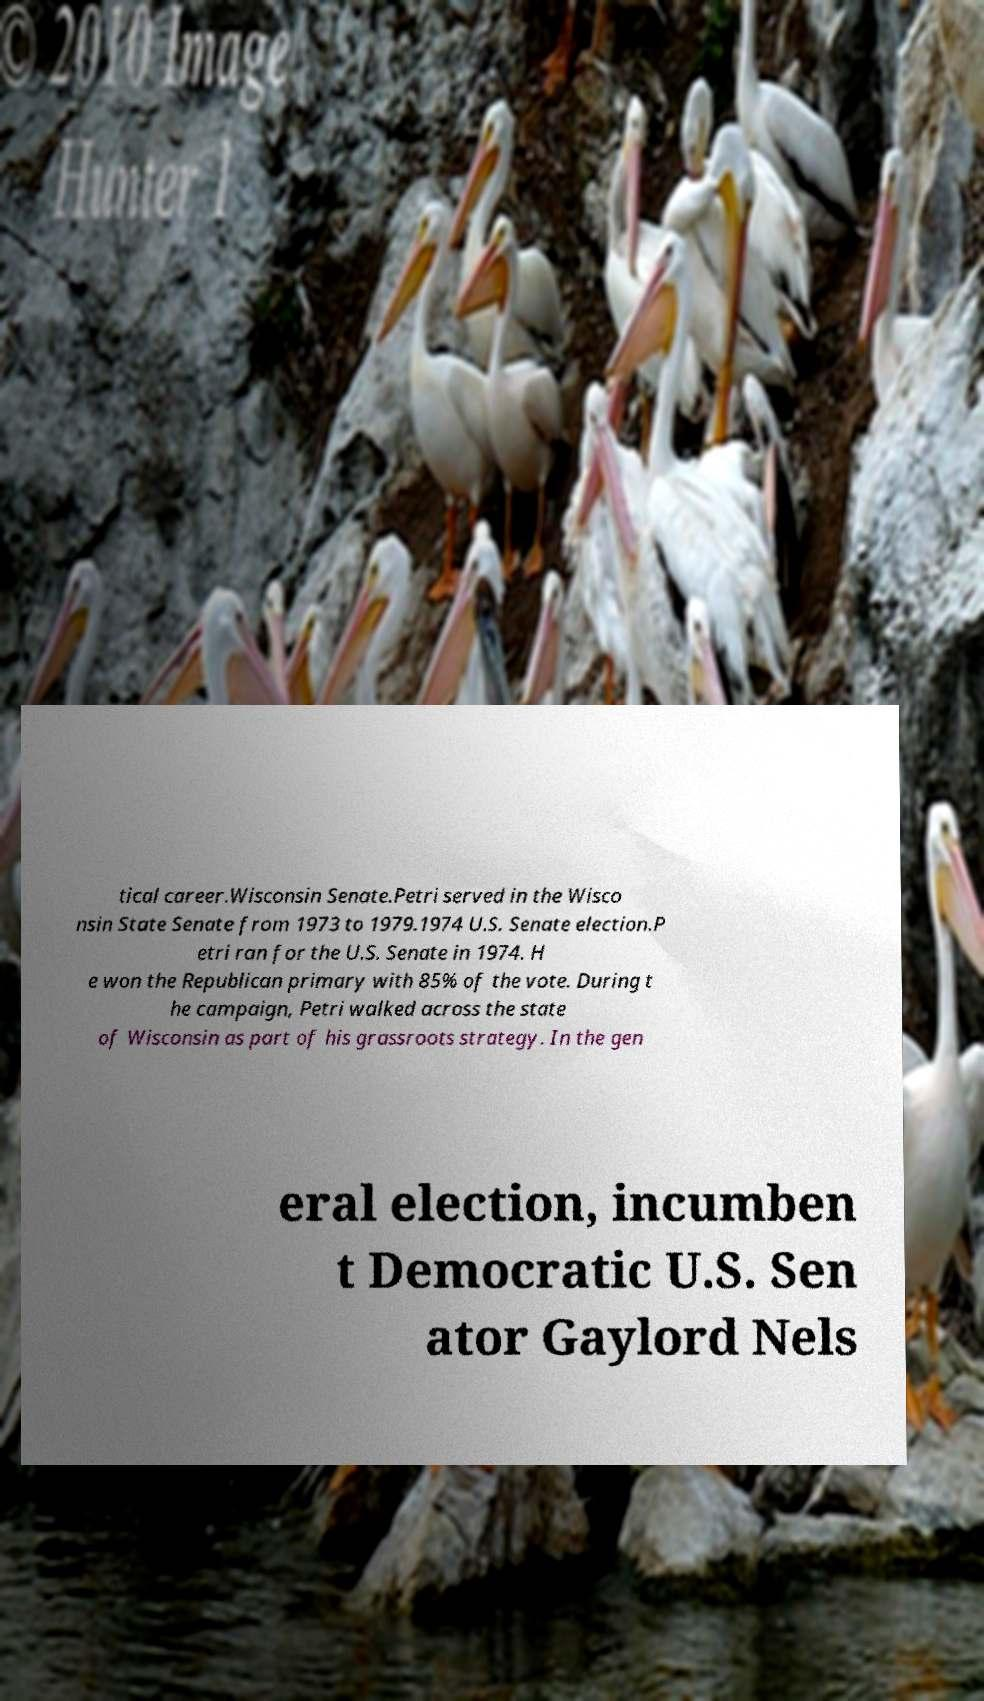I need the written content from this picture converted into text. Can you do that? tical career.Wisconsin Senate.Petri served in the Wisco nsin State Senate from 1973 to 1979.1974 U.S. Senate election.P etri ran for the U.S. Senate in 1974. H e won the Republican primary with 85% of the vote. During t he campaign, Petri walked across the state of Wisconsin as part of his grassroots strategy. In the gen eral election, incumben t Democratic U.S. Sen ator Gaylord Nels 